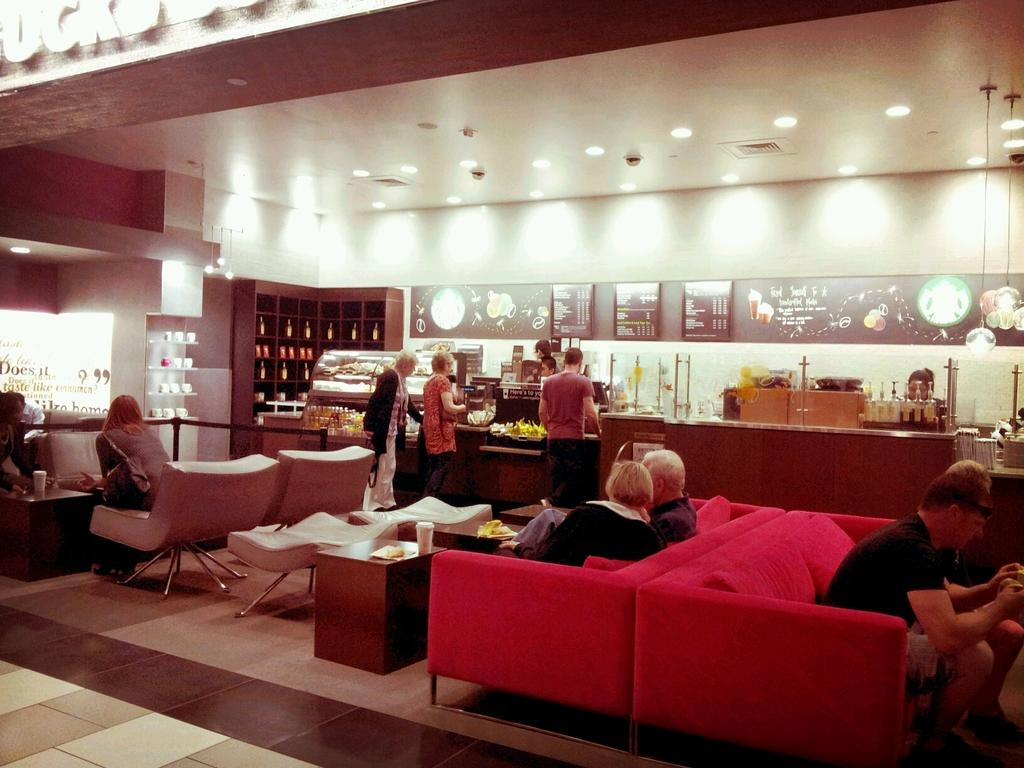What are the people in the image doing? There is a group of people sitting on a couch, and there are people standing in the image. Can you describe the lighting in the room? Lights are attached to the ceiling. What type of doll is sitting on the wrist of the person standing in the image? There is no doll present in the image, and no one is sitting on a wrist. 